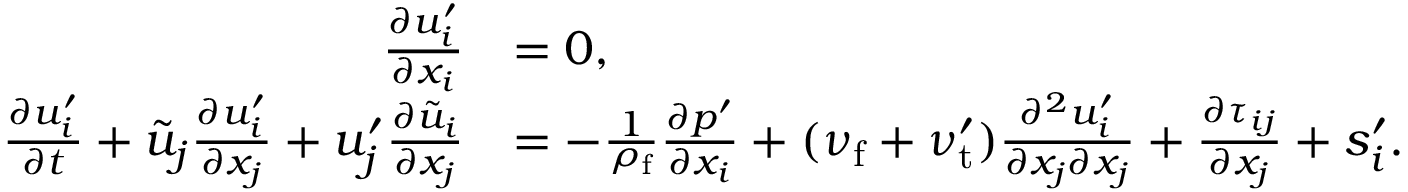Convert formula to latex. <formula><loc_0><loc_0><loc_500><loc_500>\begin{array} { r l } { \frac { \partial u _ { i } ^ { \prime } } { \partial x _ { i } } } & { = 0 , } \\ { \frac { \partial { u } _ { i } ^ { \prime } } { \partial t } + \tilde { u } _ { j } \frac { \partial u _ { i } ^ { \prime } } { \partial x _ { j } } + u _ { j } ^ { \prime } \frac { \partial \tilde { u } _ { i } } { \partial x _ { j } } } & { = - \frac { 1 } { \rho _ { f } } \frac { \partial p ^ { \prime } } { \partial x _ { i } } + ( \nu _ { f } + \nu _ { t } ^ { \prime } ) \frac { \partial ^ { 2 } u _ { i } ^ { \prime } } { \partial x _ { j } \partial x _ { j } } + \frac { \partial \tau _ { i j } } { \partial x _ { j } } + s _ { i } ^ { \prime } . } \end{array}</formula> 